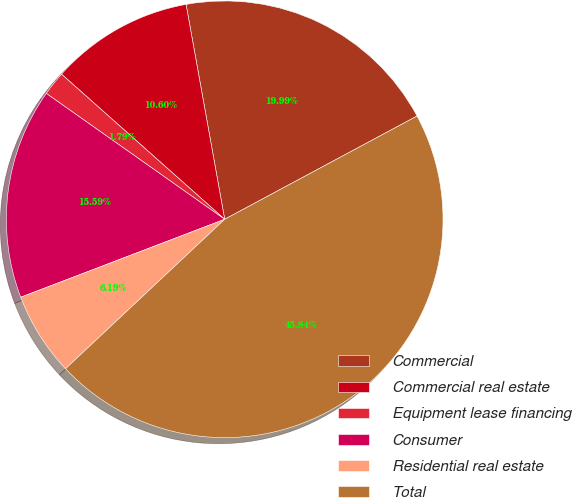<chart> <loc_0><loc_0><loc_500><loc_500><pie_chart><fcel>Commercial<fcel>Commercial real estate<fcel>Equipment lease financing<fcel>Consumer<fcel>Residential real estate<fcel>Total<nl><fcel>19.99%<fcel>10.6%<fcel>1.79%<fcel>15.59%<fcel>6.19%<fcel>45.84%<nl></chart> 